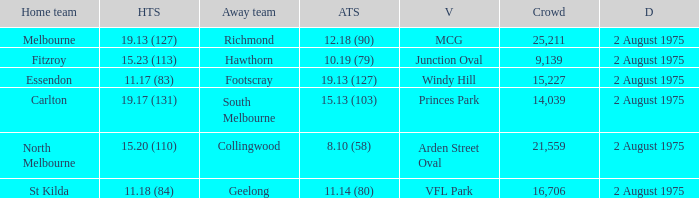Where did the home team score 11.18 (84)? VFL Park. 